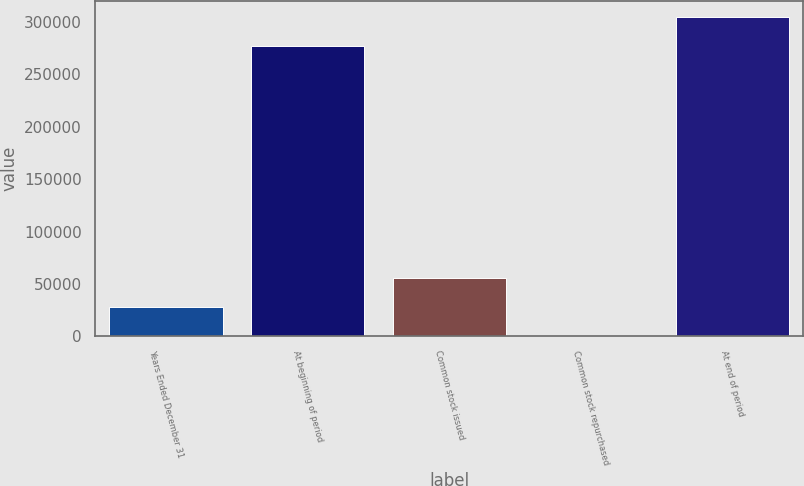Convert chart to OTSL. <chart><loc_0><loc_0><loc_500><loc_500><bar_chart><fcel>Years Ended December 31<fcel>At beginning of period<fcel>Common stock issued<fcel>Common stock repurchased<fcel>At end of period<nl><fcel>28183.4<fcel>277163<fcel>56074.8<fcel>292<fcel>305054<nl></chart> 